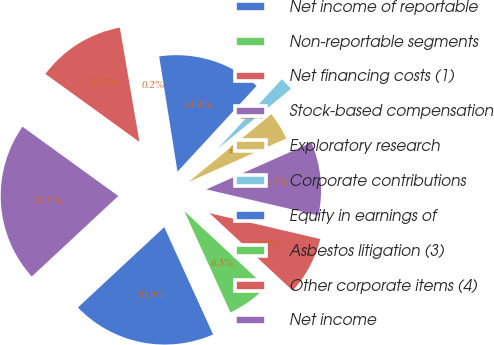Convert chart to OTSL. <chart><loc_0><loc_0><loc_500><loc_500><pie_chart><fcel>Net income of reportable<fcel>Non-reportable segments<fcel>Net financing costs (1)<fcel>Stock-based compensation<fcel>Exploratory research<fcel>Corporate contributions<fcel>Equity in earnings of<fcel>Asbestos litigation (3)<fcel>Other corporate items (4)<fcel>Net income<nl><fcel>19.87%<fcel>6.27%<fcel>8.29%<fcel>10.31%<fcel>4.25%<fcel>2.23%<fcel>14.36%<fcel>0.2%<fcel>12.33%<fcel>21.89%<nl></chart> 